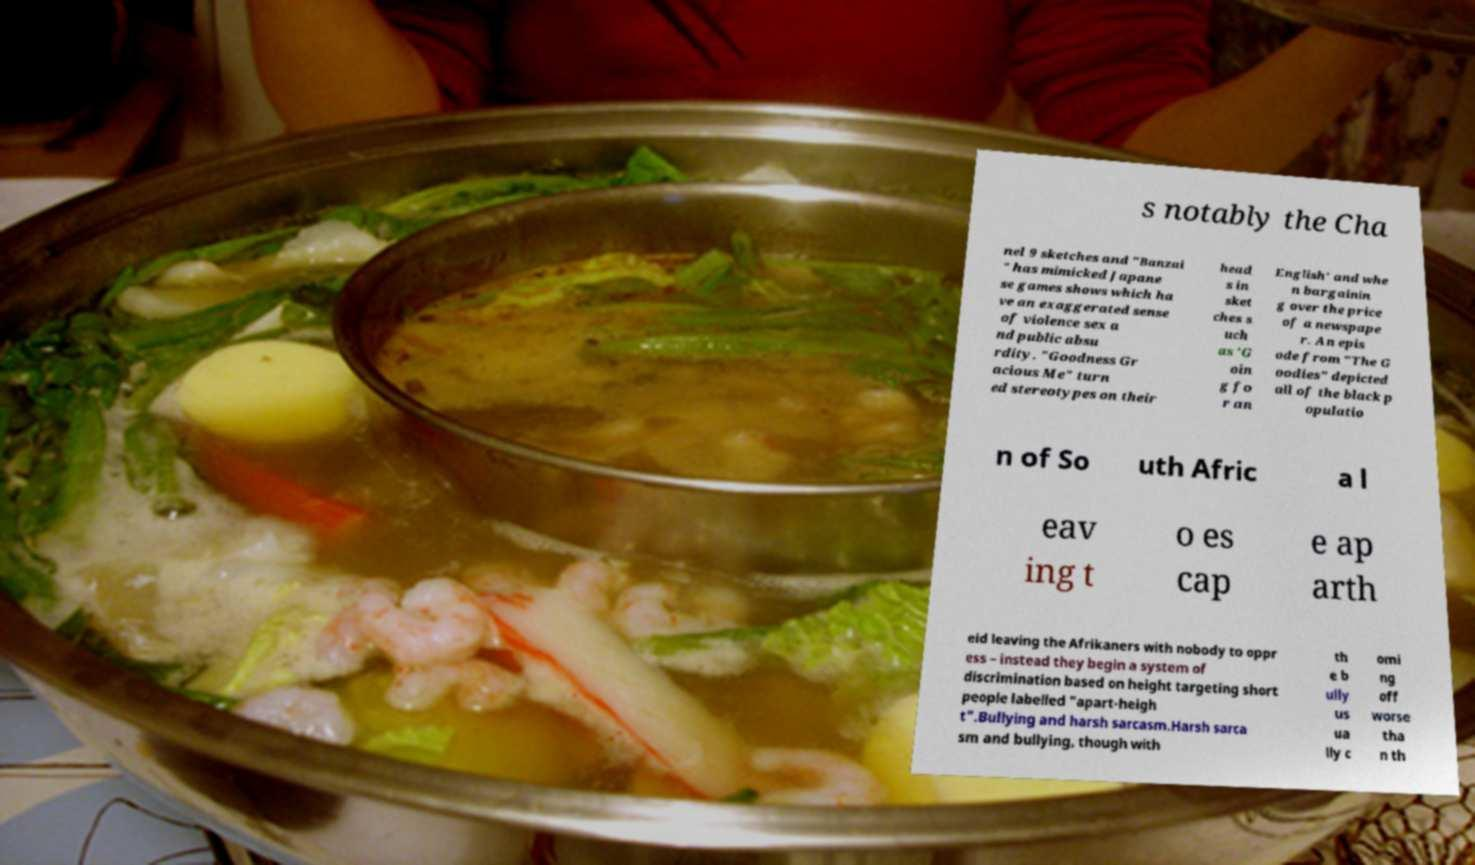Please identify and transcribe the text found in this image. s notably the Cha nel 9 sketches and "Banzai " has mimicked Japane se games shows which ha ve an exaggerated sense of violence sex a nd public absu rdity. "Goodness Gr acious Me" turn ed stereotypes on their head s in sket ches s uch as 'G oin g fo r an English' and whe n bargainin g over the price of a newspape r. An epis ode from "The G oodies" depicted all of the black p opulatio n of So uth Afric a l eav ing t o es cap e ap arth eid leaving the Afrikaners with nobody to oppr ess – instead they begin a system of discrimination based on height targeting short people labelled "apart-heigh t".Bullying and harsh sarcasm.Harsh sarca sm and bullying, though with th e b ully us ua lly c omi ng off worse tha n th 